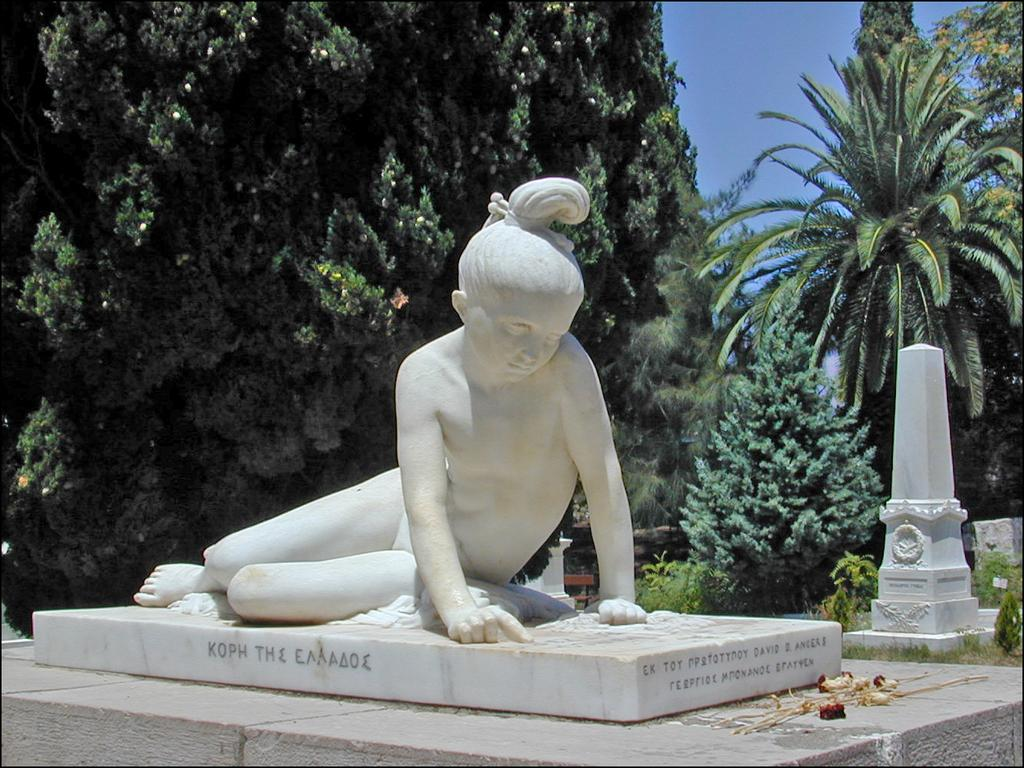What is the main subject of the image? There is a white sculpture in the image. What can be seen behind the sculpture? There are trees and plants behind the sculpture. What is visible in the background of the image? The sky is visible in the background of the image. What type of spark can be seen coming from the sculpture in the image? There is no spark present in the image; it features a white sculpture with trees and plants in the background. Is there any indication of a birthday celebration in the image? There is no indication of a birthday celebration in the image. 